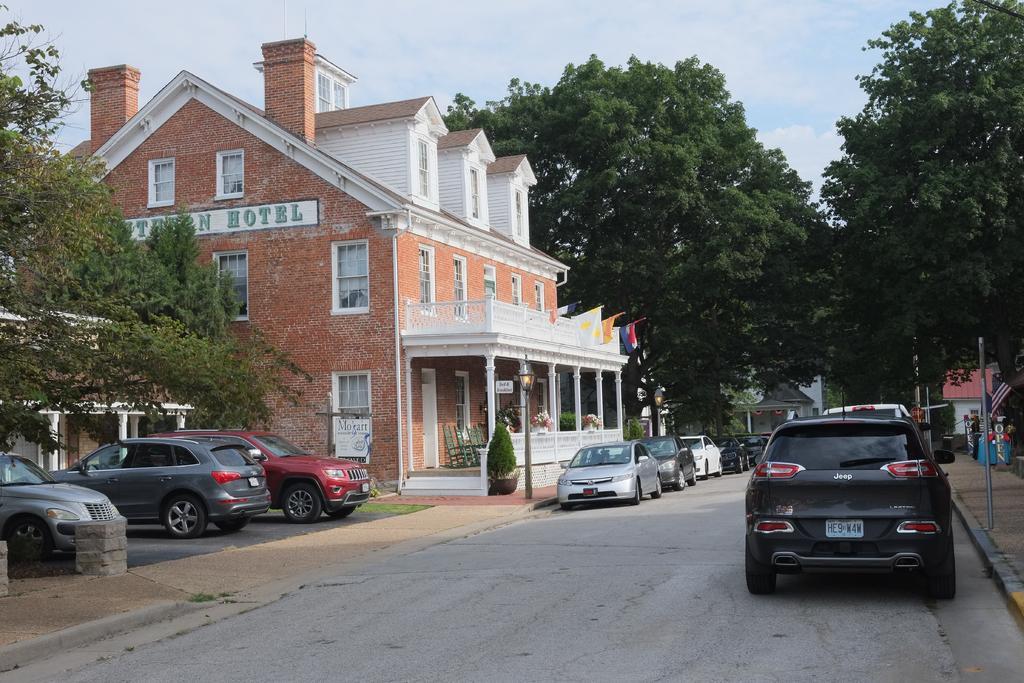Could you give a brief overview of what you see in this image? At the bottom we can see vehicles on the road. In the background there are trees, buildings, windows, light poles, chairs, flags, name board on the wall and clouds in the sky. 